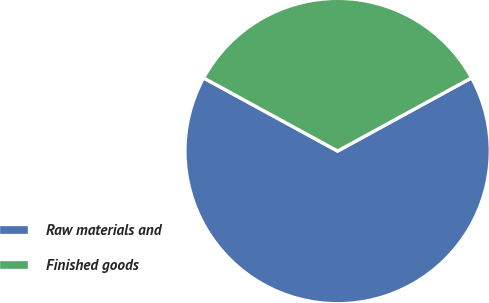Convert chart to OTSL. <chart><loc_0><loc_0><loc_500><loc_500><pie_chart><fcel>Raw materials and<fcel>Finished goods<nl><fcel>65.91%<fcel>34.09%<nl></chart> 